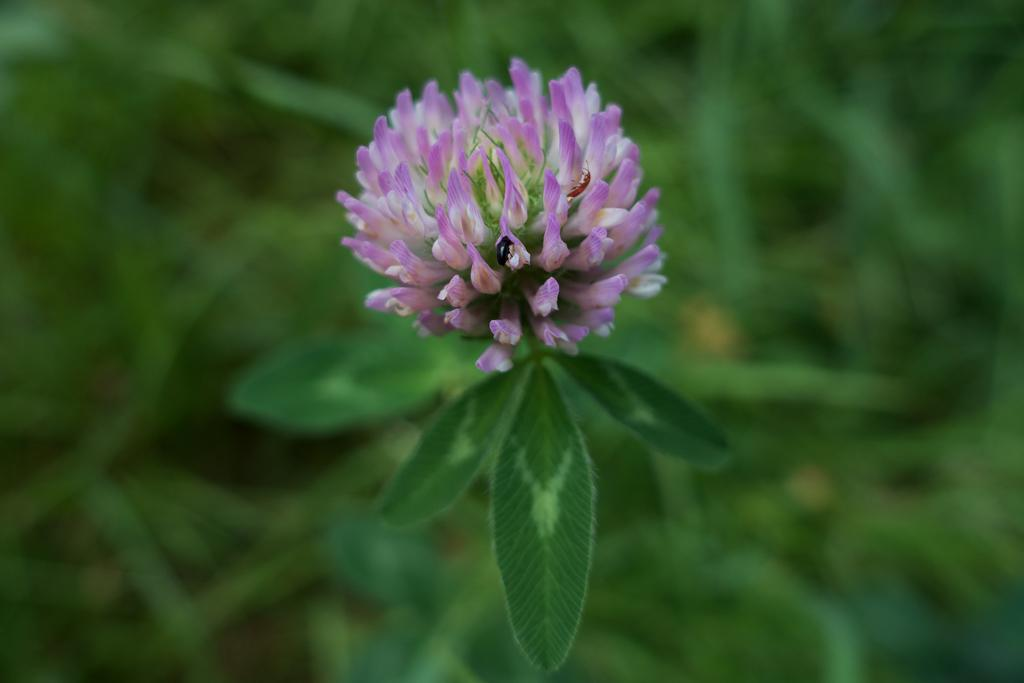What type of plant is visible in the image? The image features a plant with a flower on it. Are there any other living organisms present on the plant? Yes, there are insects on the plant in the image. How does the plant compare to the balloon in the image? There is no balloon present in the image, so it cannot be compared to the plant. 